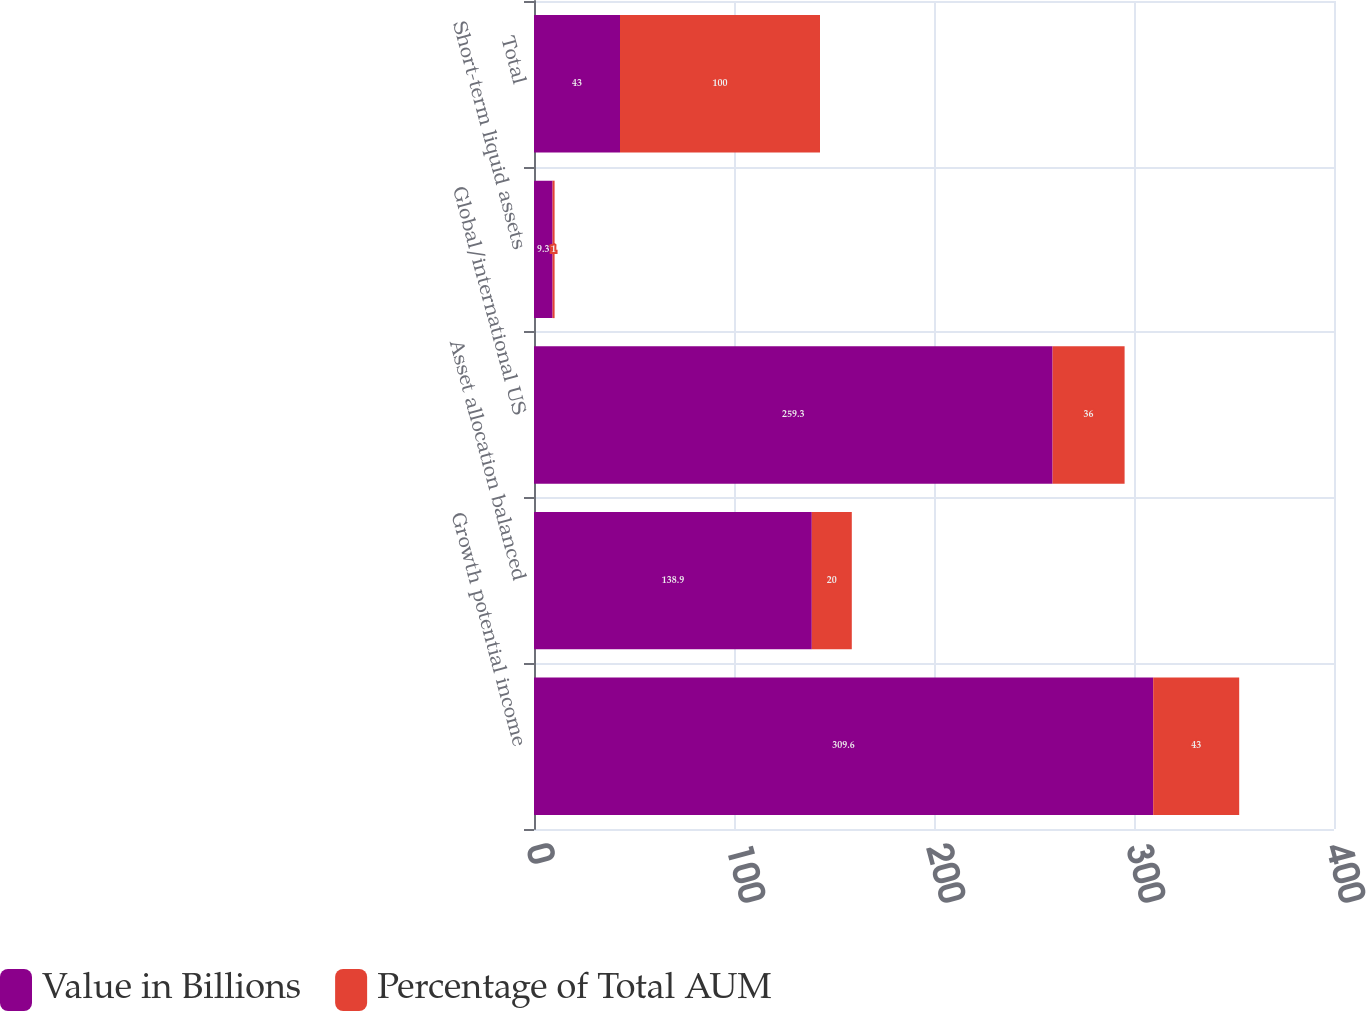<chart> <loc_0><loc_0><loc_500><loc_500><stacked_bar_chart><ecel><fcel>Growth potential income<fcel>Asset allocation balanced<fcel>Global/international US<fcel>Short-term liquid assets<fcel>Total<nl><fcel>Value in Billions<fcel>309.6<fcel>138.9<fcel>259.3<fcel>9.3<fcel>43<nl><fcel>Percentage of Total AUM<fcel>43<fcel>20<fcel>36<fcel>1<fcel>100<nl></chart> 